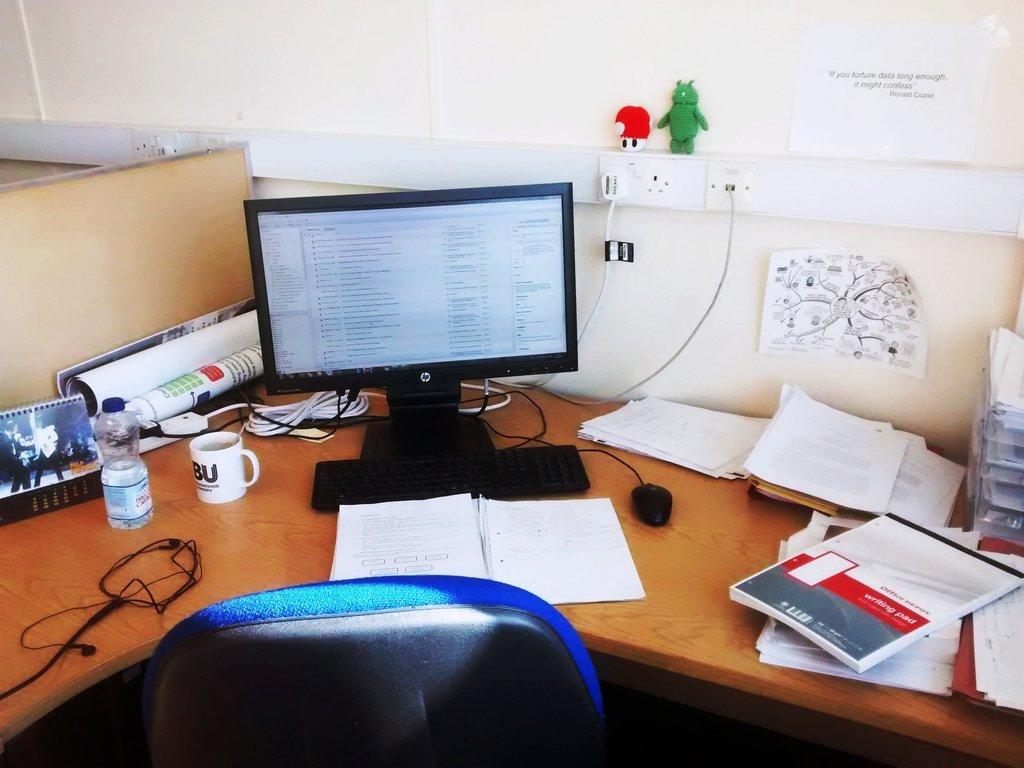Describe this image in one or two sentences. In this image i can see a monitor, computer mouse, a water bottle and other objects on the table. I can also see a chair. 